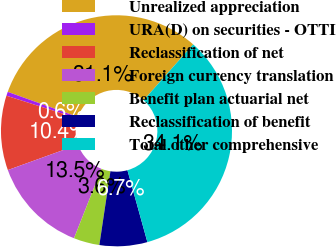Convert chart. <chart><loc_0><loc_0><loc_500><loc_500><pie_chart><fcel>Unrealized appreciation<fcel>URA(D) on securities - OTTI<fcel>Reclassification of net<fcel>Foreign currency translation<fcel>Benefit plan actuarial net<fcel>Reclassification of benefit<fcel>Total other comprehensive<nl><fcel>31.08%<fcel>0.56%<fcel>10.43%<fcel>13.49%<fcel>3.62%<fcel>6.68%<fcel>34.14%<nl></chart> 